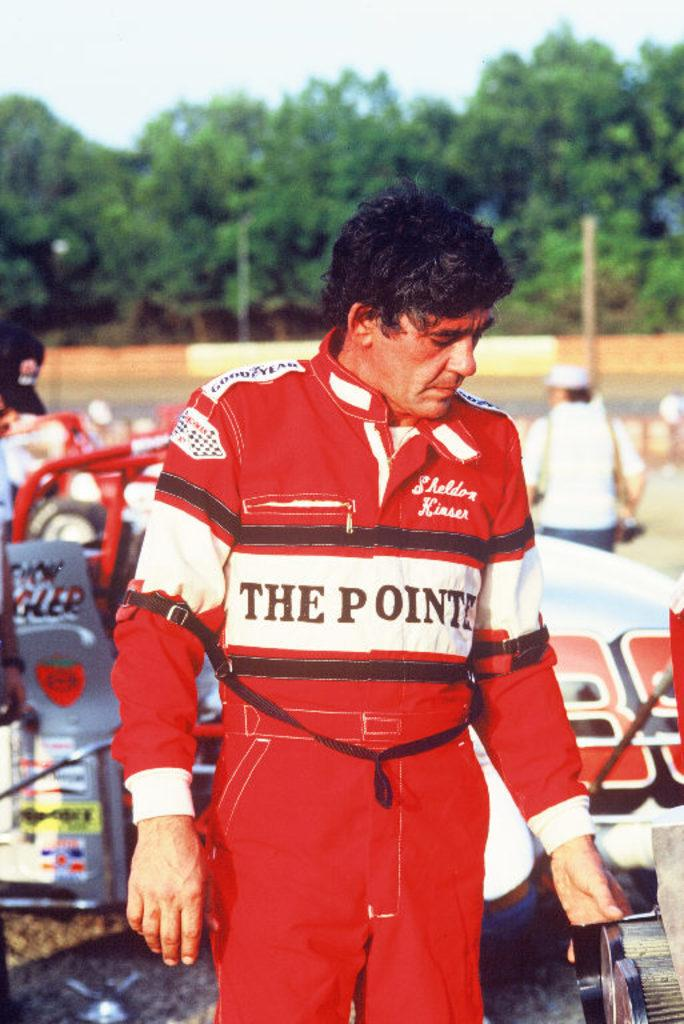<image>
Write a terse but informative summary of the picture. A man wearing a red  racing suit with THE POINTE across the front stands in front of a race car. 